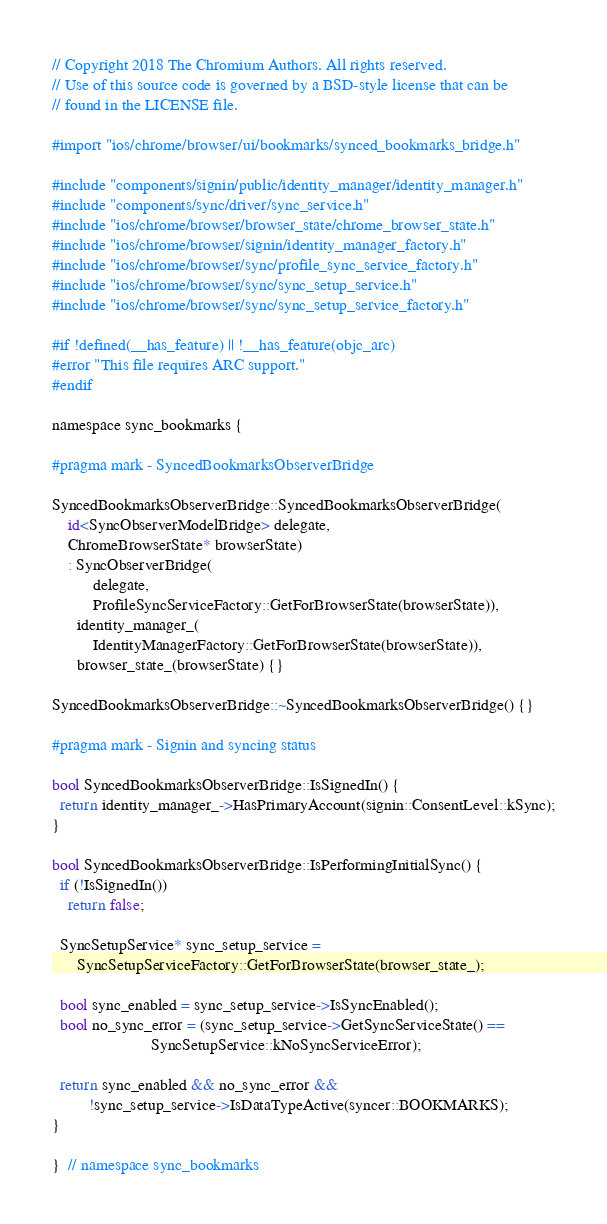Convert code to text. <code><loc_0><loc_0><loc_500><loc_500><_ObjectiveC_>// Copyright 2018 The Chromium Authors. All rights reserved.
// Use of this source code is governed by a BSD-style license that can be
// found in the LICENSE file.

#import "ios/chrome/browser/ui/bookmarks/synced_bookmarks_bridge.h"

#include "components/signin/public/identity_manager/identity_manager.h"
#include "components/sync/driver/sync_service.h"
#include "ios/chrome/browser/browser_state/chrome_browser_state.h"
#include "ios/chrome/browser/signin/identity_manager_factory.h"
#include "ios/chrome/browser/sync/profile_sync_service_factory.h"
#include "ios/chrome/browser/sync/sync_setup_service.h"
#include "ios/chrome/browser/sync/sync_setup_service_factory.h"

#if !defined(__has_feature) || !__has_feature(objc_arc)
#error "This file requires ARC support."
#endif

namespace sync_bookmarks {

#pragma mark - SyncedBookmarksObserverBridge

SyncedBookmarksObserverBridge::SyncedBookmarksObserverBridge(
    id<SyncObserverModelBridge> delegate,
    ChromeBrowserState* browserState)
    : SyncObserverBridge(
          delegate,
          ProfileSyncServiceFactory::GetForBrowserState(browserState)),
      identity_manager_(
          IdentityManagerFactory::GetForBrowserState(browserState)),
      browser_state_(browserState) {}

SyncedBookmarksObserverBridge::~SyncedBookmarksObserverBridge() {}

#pragma mark - Signin and syncing status

bool SyncedBookmarksObserverBridge::IsSignedIn() {
  return identity_manager_->HasPrimaryAccount(signin::ConsentLevel::kSync);
}

bool SyncedBookmarksObserverBridge::IsPerformingInitialSync() {
  if (!IsSignedIn())
    return false;

  SyncSetupService* sync_setup_service =
      SyncSetupServiceFactory::GetForBrowserState(browser_state_);

  bool sync_enabled = sync_setup_service->IsSyncEnabled();
  bool no_sync_error = (sync_setup_service->GetSyncServiceState() ==
                        SyncSetupService::kNoSyncServiceError);

  return sync_enabled && no_sync_error &&
         !sync_setup_service->IsDataTypeActive(syncer::BOOKMARKS);
}

}  // namespace sync_bookmarks
</code> 